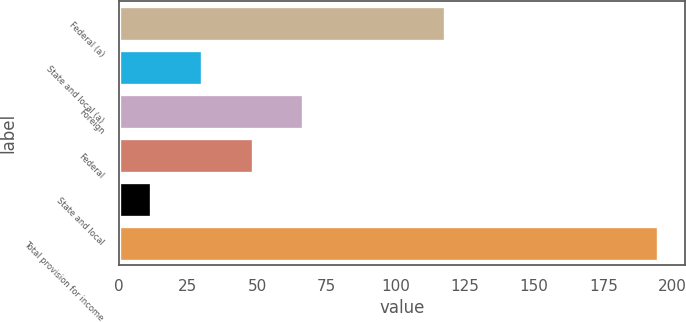Convert chart to OTSL. <chart><loc_0><loc_0><loc_500><loc_500><bar_chart><fcel>Federal (a)<fcel>State and local (a)<fcel>Foreign<fcel>Federal<fcel>State and local<fcel>Total provision for income<nl><fcel>118<fcel>30.11<fcel>66.73<fcel>48.42<fcel>11.8<fcel>194.9<nl></chart> 